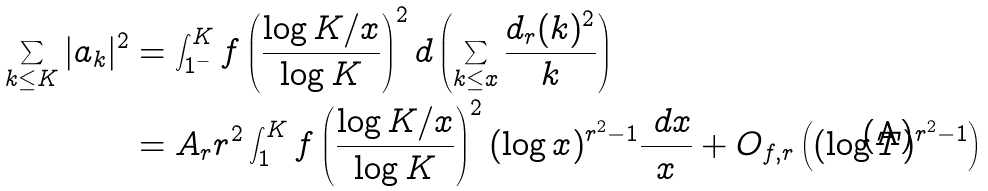Convert formula to latex. <formula><loc_0><loc_0><loc_500><loc_500>\sum _ { k \leq K } | a _ { k } | ^ { 2 } & = \int _ { 1 ^ { - } } ^ { K } f \left ( \frac { \log K / x } { \log K } \right ) ^ { 2 } d \left ( \sum _ { k \leq x } \frac { d _ { r } ( k ) ^ { 2 } } { k } \right ) \\ & = A _ { r } r ^ { 2 } \int _ { 1 } ^ { K } f \left ( \frac { \log K / x } { \log K } \right ) ^ { 2 } ( \log x ) ^ { r ^ { 2 } - 1 } \frac { \ d x } { x } + O _ { f , r } \left ( ( \log T ) ^ { r ^ { 2 } - 1 } \right )</formula> 